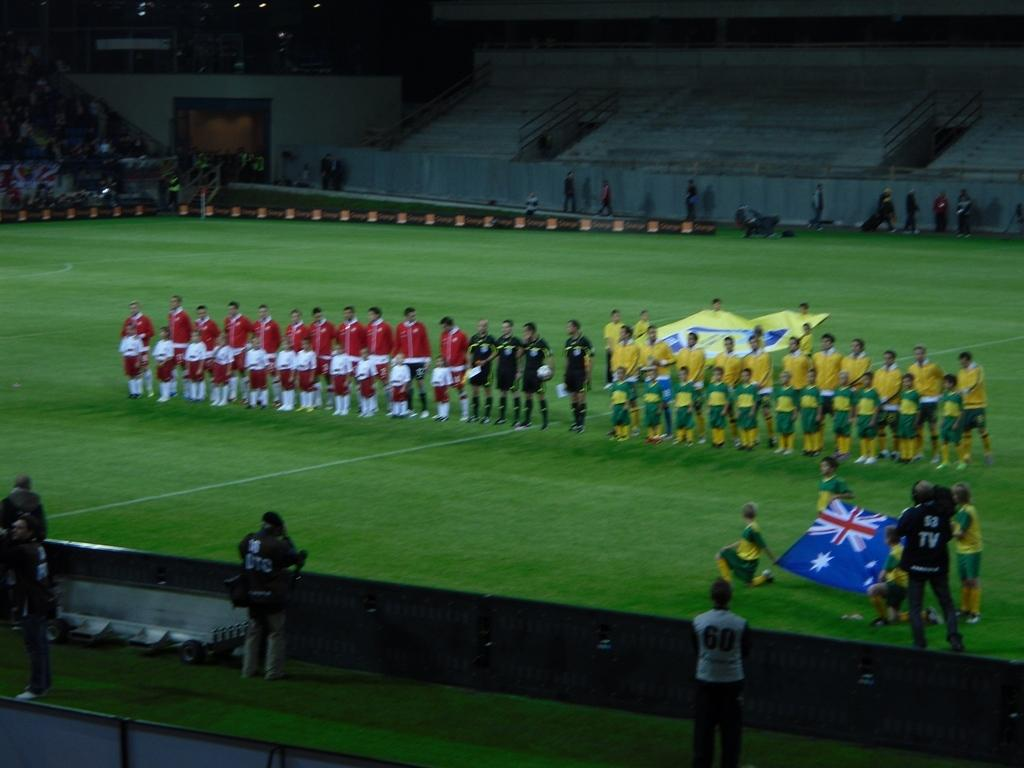Provide a one-sentence caption for the provided image. a field with two teams standing in line and a man in the corner with TV written on his back filming. 